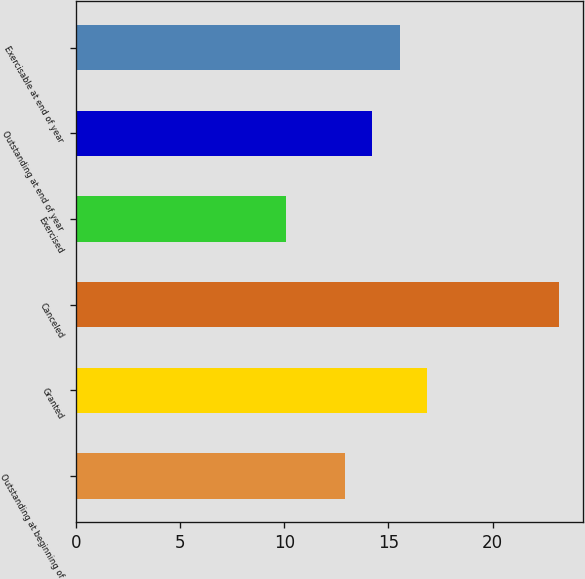Convert chart to OTSL. <chart><loc_0><loc_0><loc_500><loc_500><bar_chart><fcel>Outstanding at beginning of<fcel>Granted<fcel>Canceled<fcel>Exercised<fcel>Outstanding at end of year<fcel>Exercisable at end of year<nl><fcel>12.92<fcel>16.85<fcel>23.2<fcel>10.08<fcel>14.23<fcel>15.54<nl></chart> 